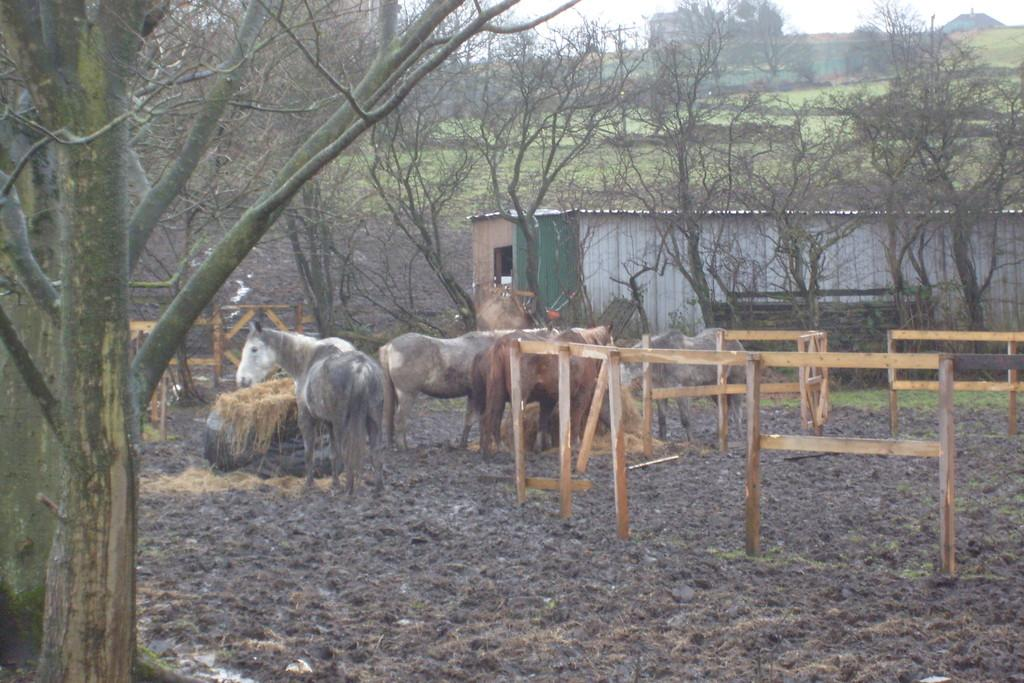What animals are in the center of the image? There are horses in the center of the image. What can be seen surrounding the horses? There is a fence in the image. What structures are visible in the background? There is a shed in the background of the image. What type of vegetation is visible in the background? There are trees in the background of the image. What is visible above the scene? The sky is visible in the image. What type of thread is being used to create the horses in the image? There is no thread present in the image; the horses are depicted as real animals. 